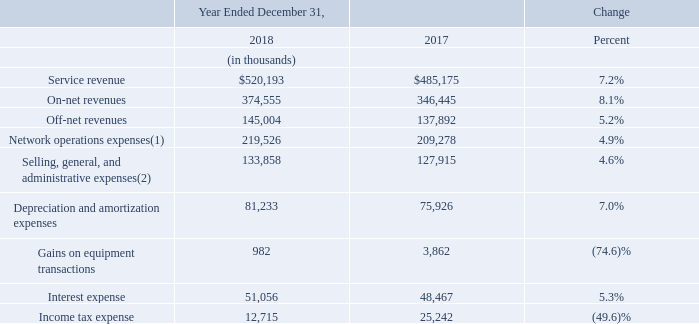Year Ended December 31, 2018 Compared to the Year Ended December 31, 2017
Our management reviews and analyzes several key financial measures in order to manage our business and assess the quality of and variability of our service revenue, operating results and cash flows. The following summary tables present a comparison of our results of operations with respect to certain key financial measures. The comparisons illustrated in the tables are discussed in greater detail below.
(1) Includes non-cash equity-based compensation expense of $895 and $604 for 2018 and 2017, respectively.
(2) Includes non-cash equity-based compensation expense of $16,813 and $12,686 for 2018 and 2017, respectively.
Service Revenue. Our service revenue increased 7.2% from 2017 to 2018. Exchange rates positively impacted our increase in service revenue by approximately $4.0 million. All foreign currency comparisons herein reflect results for 2018 translated at the average foreign currency exchange rates for 2017. We increased our total service revenue by increasing the number of sales representatives selling our services, by expanding our network, by adding additional buildings to our network, by increasing our penetration into the buildings connected to our network and by gaining market share by offering our services at lower prices than our competitors.
Revenue recognition standards include guidance relating to any tax assessed by a governmental authority that is directly imposed on a revenue-producing transaction between a seller and a customer and may include, but is not limited to, gross receipts taxes, Universal Service Fund fees and certain state regulatory fees. We record these taxes billed to our customers on a gross basis (as service revenue and network operations expense) in our consolidated statements of operations. The impact of these taxes including the Universal Service Fund resulted in an increase to our revenues from 2017 to 2018 of approximately $1.6 million.
Our net-centric customers tend to purchase their service on a price per megabit basis. Our corporate customers tend to utilize a small portion of their allocated bandwidth on their connections and tend to purchase their service on a per connection basis. Revenues from our corporate and net-centric customers represented 64.9% and 35.1% of total service revenue, respectively, for 2018 and represented 62.3% and 37.7% of total service revenue, respectively, for 2017. Revenues from corporate customers increased 11.8% to $337.8 million for 2018 from $302.1 million for 2017 primarily due to an increase in our number of our corporate customers. Revenues from our net-centric customers decreased by 0.4% to $182.3 million for 2018 from $183.1 million for 2017 primarily due to an increase in our number of net-centric customers being offset by a decline in our average price per megabit. Our revenue from our net- centric customers has declined as a percentage of our total revenue and grew at a slower rate than our corporate customer revenue because net-centric customers purchase our services based upon a price per megabit basis and our average price per megabit declined by 25.9% from 2017 to 2018. Additionally, the net-centric market experiences a greater level of pricing pressure than the corporate market and net-centric customers who renew their service with us expect their renewed service to be at a lower price than their current price. We expect that our average price per megabit will continue to decline at similar rates which would result in our corporate revenues continuing to represent a greater portion of our total revenues and our net-centric revenues continuing to grow at a lower rate than our corporate revenues. Additionally, the impact of foreign exchange rates has a more significant impact on our net- centric revenues.
Our on-net revenues increased 8.1% from 2017 to 2018. We increased the number of our on-net customer connections by 12.1% at December 31, 2018 from December 31, 2017. On-net customer connections increased at a greater rate than on-net revenues primarily due to the 5.1% decline in our on-net ARPU, primarily from a decline in ARPU for our net-centric customers. ARPU is determined by dividing revenue for the period by the average customer connections for that period. Our average price per megabit for our installed base of customers is determined by dividing the aggregate monthly recurring fixed charges for those customers by the aggregate committed data rate for the same customers. The decline in on-net ARPU is partly attributed to volume and term based pricing discounts. Additionally, on-net customers who cancel their service from our installed base of customers, in general, have an ARPU that is greater than the ARPU for our new customers due to declining prices primarily for our on-net services sold to our net-centric customers. These trends resulted in the reduction to our on-net ARPU and a 25.9% decline in our average price per megabit for our installed base of customers.
Our off-net revenues increased 5.2% from 2017 to 2018. Our off-net revenues increased as we increased the number of our off-net customer connections by 10.3% at December 31, 2018 from December 31, 2017. Our off-net customer connections increased at a greater rate than our off-net revenue primarily due to the 6.8% decrease in our off-net ARPU.
Network Operations Expenses. Network operations expenses include the costs of personnel associated with service delivery, network management, and customer support, network facilities costs, fiber and equipment maintenance fees, leased circuit costs, access and facilities fees paid to building owners and excise taxes billed to our customers and recorded on a gross basis. Non-cash equity-based compensation expense is included in network operations expenses consistent with the classification of the employee's salary and other compensation. Our network operations expenses, including non-cash equity-based compensation expense, increased 4.9% from 2017 to 2018 as we were connected to 11.9% more customer connections and we were connected to 170 more on-net buildings as of December 31, 2018 compared to December 31, 2017. The increase in network operations expense is primarily attributable to an increase in costs related to our network and facilities expansion activities and the increase in our off- net revenues. When we provide off-net services we also assume the cost of the associated tail circuits.
Selling, General, and Administrative Expenses (“SG&A”). Our SG&A expenses, including non-cash equity- based compensation expense, increased 4.6% from 2017 to 2018. Non cash equity-based compensation expense is included in SG&A expenses consistent with the classification of the employee's salary and other compensation and was $16.8 million for 2018 and $12.7 million for 2017. SG&A expenses increased primarily from an increase in salaries and related costs required to support our expansion and increases in our sales efforts and an increase in our headcount partly offset by a $1.1 million decrease in our legal fees primarily associated with U.S. net neutrality and interconnection regulatory matters and by the $1.3 million reduction in commission expense from the impact of the new revenue accounting standard which requires us to capitalize certain commissions paid to our sales agents and sales employees. Our sales force headcount increased by 7.8% from 574 at December 31, 2017 to 619 at December 31, 2018 and our total headcount increased by 4.8% from 929 at December 31, 2017 to 974 at December 31, 2018.
Depreciation and Amortization Expenses. Our depreciation and amortization expenses increased 7.0% from 2017 to 2018. The increase is primarily due to the depreciation expense associated with the increase related to newly deployed fixed assets more than offsetting the decline in depreciation expense from fully depreciated fixed assets.
Gains on Equipment Transactions. We exchanged certain used network equipment and cash consideration for new network equipment resulting in gains of $1.0 million for 2018 and $3.9 million for 2017. The gains are based upon the excess of the estimated fair value of the new network equipment over the carrying amount of the returned used network equipment and the cash paid. The reduction in gains from 2017 to 2018 was due to purchasing more equipment under the exchange program in 2017 than we purchased in 2018.
Interest Expense. Interest expense results from interest incurred on our $445.0 million of senior secured notes, interest incurred on our $189.2 million of senior unsecured notes, interest on our installment payment agreement and interest on our finance lease obligations. Our interest expense increased by 5.3% for 2018 from 2017 primarily due to the issuance of $70.0 million of senior secured notes in August 2018 and an increase in our finance lease obligations.
Income Tax Expense. Our income tax expense was $12.7 million for 2018 and $25.2 million for 2017. The decrease in our income tax expense was primarily related to an increase in deferred income tax expense for 2017 primarily due to the impact of the Tax Cuts and Jobs Act (the "Act"). On December 22, 2017, the President of the United States signed into law the Act. The Act amended the Internal Revenue Code and reduced the corporate tax rate from a maximum rate of 35% to a flat 21% rate. The rate reduction was effective on January 1, 2018 and may reduce our future income taxes payable once we become a cash taxpayer in the United States. As a result of the reduction in the corporate income tax rate and other provisions under the Act, we were required to revalue our net deferred tax asset at December 31, 2017 resulting in a reduction in our net deferred tax asset of $9.0 million and we also recorded a transition tax of $2.3 million related to our foreign operations for a total income tax expense of approximately $11.3 million, which was recorded as additional noncash income tax expense in 2017.
Buildings On-net. As of December 31, 2018 and 2017 we had a total of 2,676 and 2,506 on-net buildings connected to our network, respectively.
What are the respective on-cash equity-based compensation expense included in network operations expenses in 2018 and 2017?
Answer scale should be: thousand. $895, $604. What are the respective on-cash equity-based compensation expense included in selling, general, and administrative expenses in 2018 and 2017?
Answer scale should be: thousand. $16,813, $12,686. What are the respective service revenue earned by the company in 2017 and 2018?
Answer scale should be: thousand. $485,175, $520,193. What is the average service revenue earned by the company in 2017 and 2018?
Answer scale should be: thousand. (485,175 + 520,193)/2 
Answer: 502684. What is the average on-net revenue earned by the company in 2017 and 2018?
Answer scale should be: thousand. (346,445 + 374,555)/2 
Answer: 360500. What is the average off-net revenue earned by the company in 2017 and 2018?
Answer scale should be: thousand. (137,892 + 145,004)/2 
Answer: 141448. 